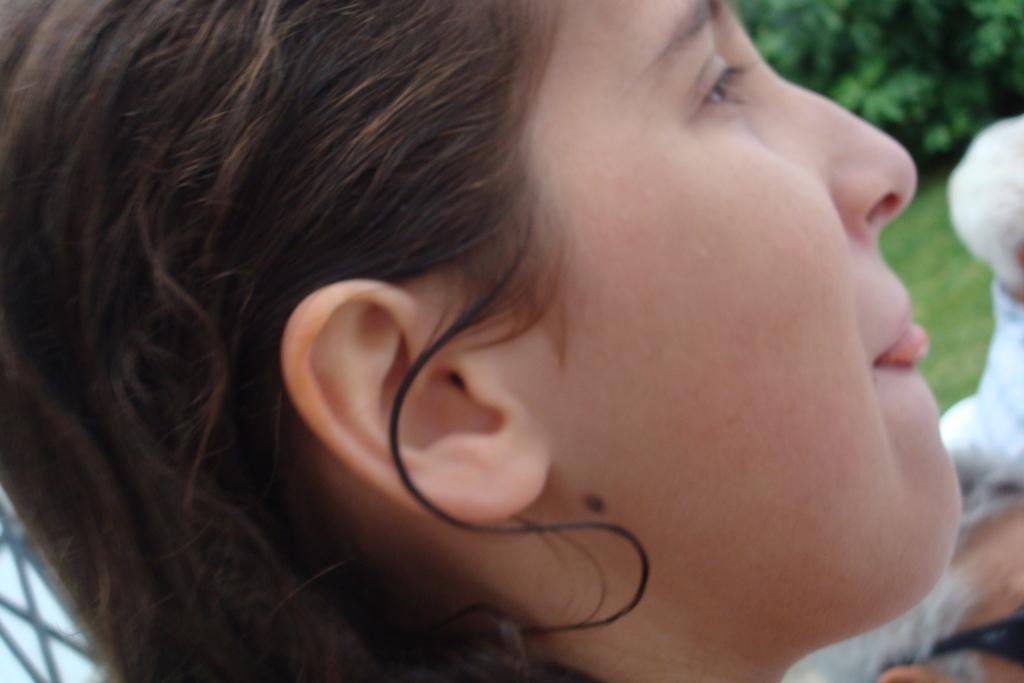What is the main subject of the image? There is a girl's face in the image. Can you describe any specific features on the girl's face? There is a mole on the girl's face. What can be seen in the background of the image? There are green leaves and green grass in the background of the image. What color is the object in the background of the image? There is a white color thing in the background of the image. What type of yam is being prepared by the girl's aunt in the image? There is no girl's aunt or yam present in the image. What type of oil is being used to cook the yam in the image? There is no yam or oil present in the image. 